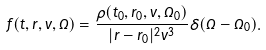Convert formula to latex. <formula><loc_0><loc_0><loc_500><loc_500>f ( t , { r } , v , \Omega ) = \frac { \rho ( t _ { 0 } , { r } _ { 0 } , v , \Omega _ { 0 } ) } { | { r } - { r } _ { 0 } | ^ { 2 } v ^ { 3 } } \delta ( \Omega - \Omega _ { 0 } ) .</formula> 